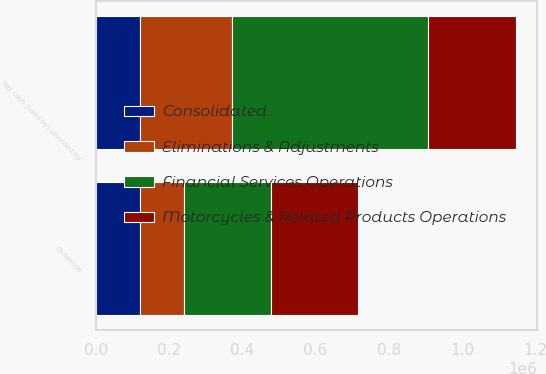Convert chart. <chart><loc_0><loc_0><loc_500><loc_500><stacked_bar_chart><ecel><fcel>Dividends<fcel>Net cash (used by) provided by<nl><fcel>Motorcycles & Related Products Operations<fcel>238300<fcel>238300<nl><fcel>Eliminations & Adjustments<fcel>120000<fcel>251481<nl><fcel>Consolidated<fcel>120000<fcel>120000<nl><fcel>Financial Services Operations<fcel>238300<fcel>536096<nl></chart> 